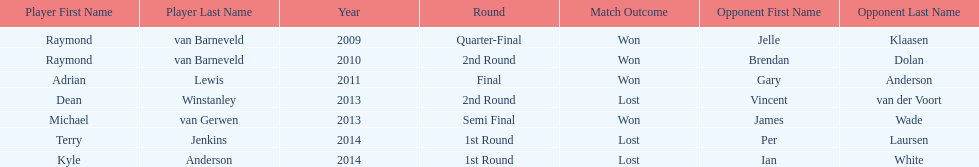Name a year with more than one game listed. 2013. 